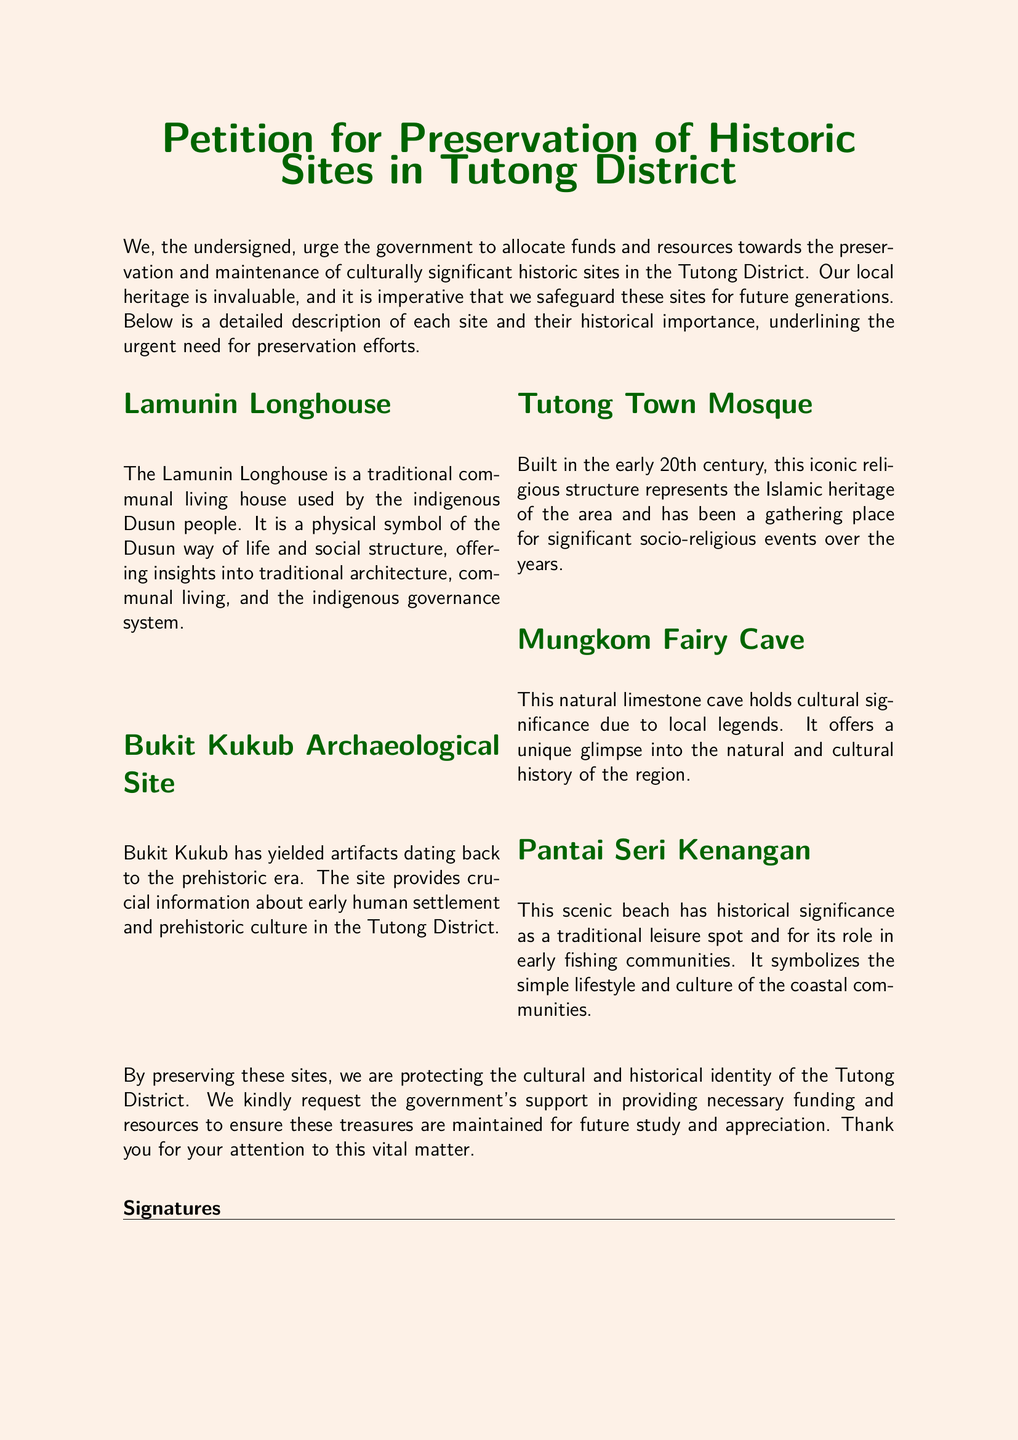What is the title of the petition? The title is the main heading of the document, which outlines the purpose of the petition.
Answer: Petition for Preservation of Historic Sites in Tutong District How many historic sites are listed in the petition? The number of sites is mentioned in the document under the descriptions section.
Answer: Five What is the historical significance of the Lamunin Longhouse? This information summarizes the role of the Lamunin Longhouse in the context of cultural heritage.
Answer: Dusun way of life and social structure Which site represents the Islamic heritage of the area? The document describes one of the sites that is significant for Islamic heritage.
Answer: Tutong Town Mosque What type of site is Mungkom Fairy Cave? Describes the category of the Mungkom Fairy Cave based on the context provided in the document.
Answer: Natural limestone cave What request is made to the government in the petition? The petition outlines a specific appeal directed to the government regarding allocation of resources.
Answer: Allocate funds and resources What community is associated with Pantai Seri Kenangan? This refers to the group of people linked to the specific site mentioned in the petition.
Answer: Coastal communities In what century was the Tutong Town Mosque built? This indicates the time frame of the construction of a significant religious structure mentioned.
Answer: Early 20th century What should the government support for the historic sites? The petition emphasizes a specific type of support needed for the sites mentioned.
Answer: Funding and resources 